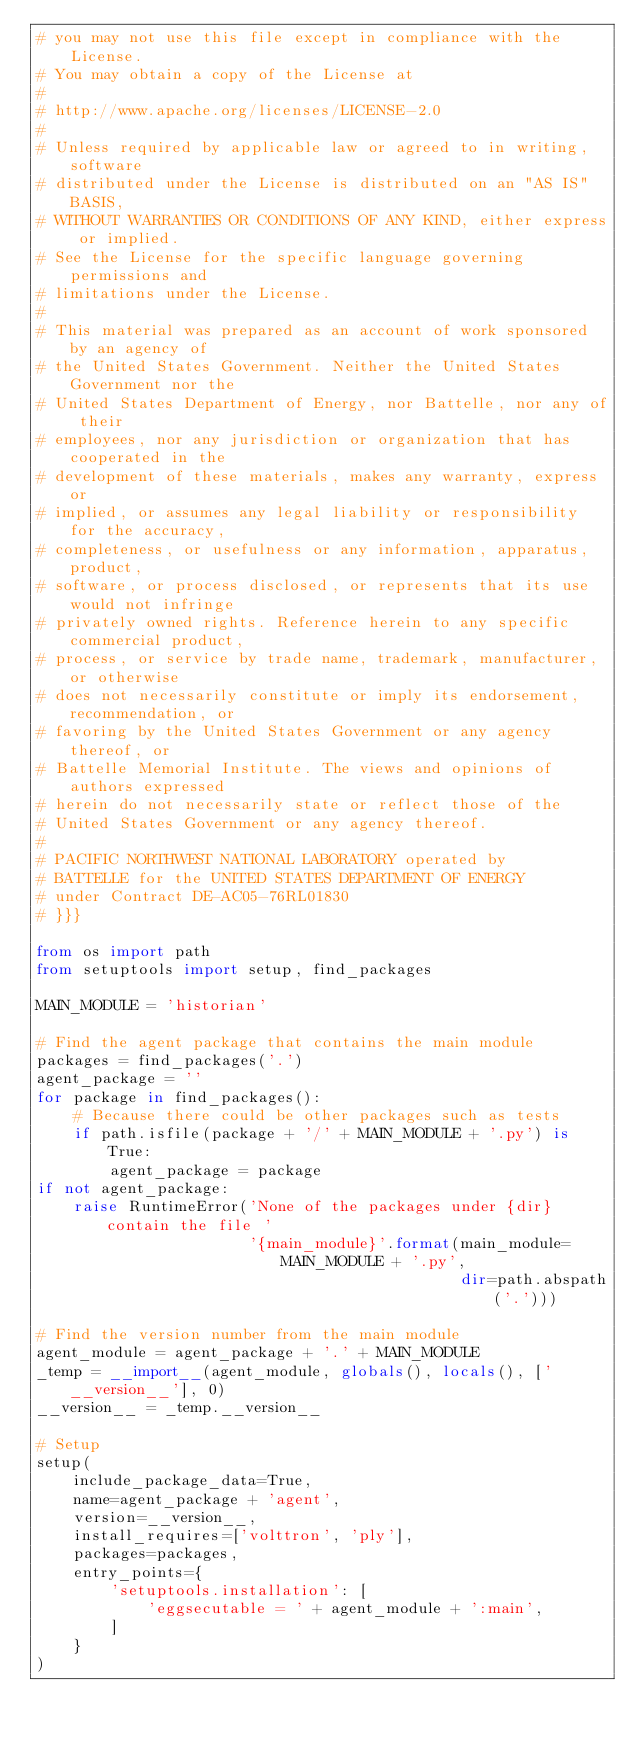Convert code to text. <code><loc_0><loc_0><loc_500><loc_500><_Python_># you may not use this file except in compliance with the License.
# You may obtain a copy of the License at
#
# http://www.apache.org/licenses/LICENSE-2.0
#
# Unless required by applicable law or agreed to in writing, software
# distributed under the License is distributed on an "AS IS" BASIS,
# WITHOUT WARRANTIES OR CONDITIONS OF ANY KIND, either express or implied.
# See the License for the specific language governing permissions and
# limitations under the License.
#
# This material was prepared as an account of work sponsored by an agency of
# the United States Government. Neither the United States Government nor the
# United States Department of Energy, nor Battelle, nor any of their
# employees, nor any jurisdiction or organization that has cooperated in the
# development of these materials, makes any warranty, express or
# implied, or assumes any legal liability or responsibility for the accuracy,
# completeness, or usefulness or any information, apparatus, product,
# software, or process disclosed, or represents that its use would not infringe
# privately owned rights. Reference herein to any specific commercial product,
# process, or service by trade name, trademark, manufacturer, or otherwise
# does not necessarily constitute or imply its endorsement, recommendation, or
# favoring by the United States Government or any agency thereof, or
# Battelle Memorial Institute. The views and opinions of authors expressed
# herein do not necessarily state or reflect those of the
# United States Government or any agency thereof.
#
# PACIFIC NORTHWEST NATIONAL LABORATORY operated by
# BATTELLE for the UNITED STATES DEPARTMENT OF ENERGY
# under Contract DE-AC05-76RL01830
# }}}

from os import path
from setuptools import setup, find_packages

MAIN_MODULE = 'historian'

# Find the agent package that contains the main module
packages = find_packages('.')
agent_package = ''
for package in find_packages():
    # Because there could be other packages such as tests
    if path.isfile(package + '/' + MAIN_MODULE + '.py') is True:
        agent_package = package
if not agent_package:
    raise RuntimeError('None of the packages under {dir} contain the file '
                       '{main_module}'.format(main_module=MAIN_MODULE + '.py',
                                              dir=path.abspath('.')))

# Find the version number from the main module
agent_module = agent_package + '.' + MAIN_MODULE
_temp = __import__(agent_module, globals(), locals(), ['__version__'], 0)
__version__ = _temp.__version__

# Setup
setup(
    include_package_data=True,
    name=agent_package + 'agent',
    version=__version__,
    install_requires=['volttron', 'ply'],
    packages=packages,
    entry_points={
        'setuptools.installation': [
            'eggsecutable = ' + agent_module + ':main',
        ]
    }
)
</code> 